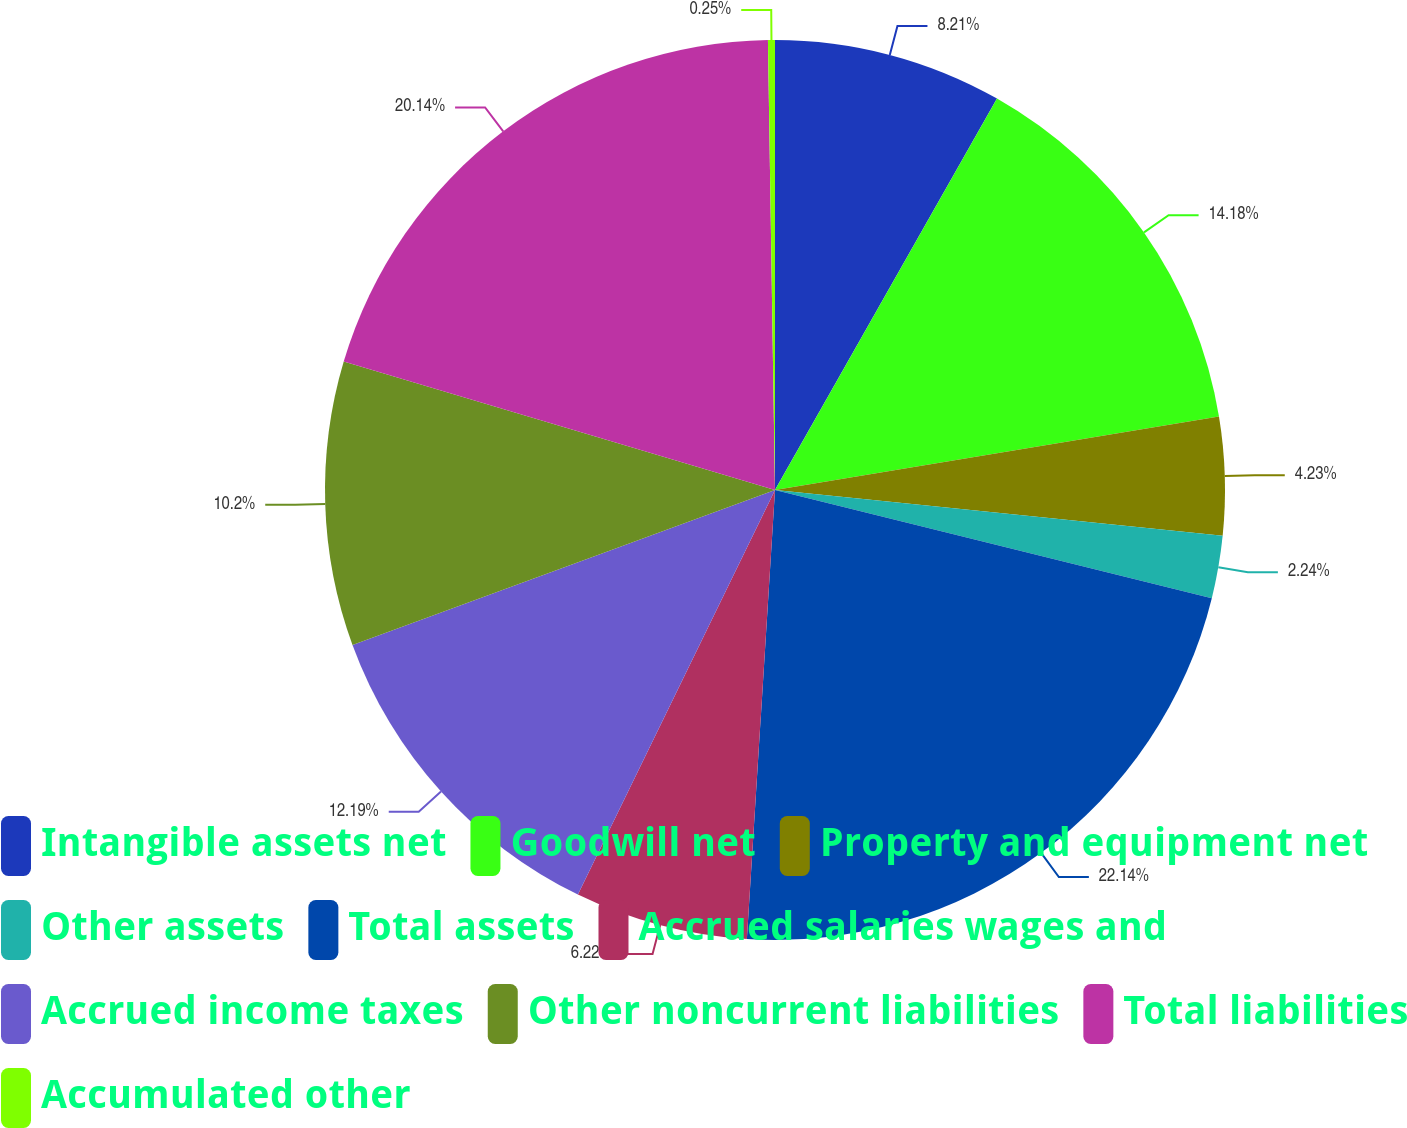Convert chart. <chart><loc_0><loc_0><loc_500><loc_500><pie_chart><fcel>Intangible assets net<fcel>Goodwill net<fcel>Property and equipment net<fcel>Other assets<fcel>Total assets<fcel>Accrued salaries wages and<fcel>Accrued income taxes<fcel>Other noncurrent liabilities<fcel>Total liabilities<fcel>Accumulated other<nl><fcel>8.21%<fcel>14.18%<fcel>4.23%<fcel>2.24%<fcel>22.13%<fcel>6.22%<fcel>12.19%<fcel>10.2%<fcel>20.14%<fcel>0.25%<nl></chart> 